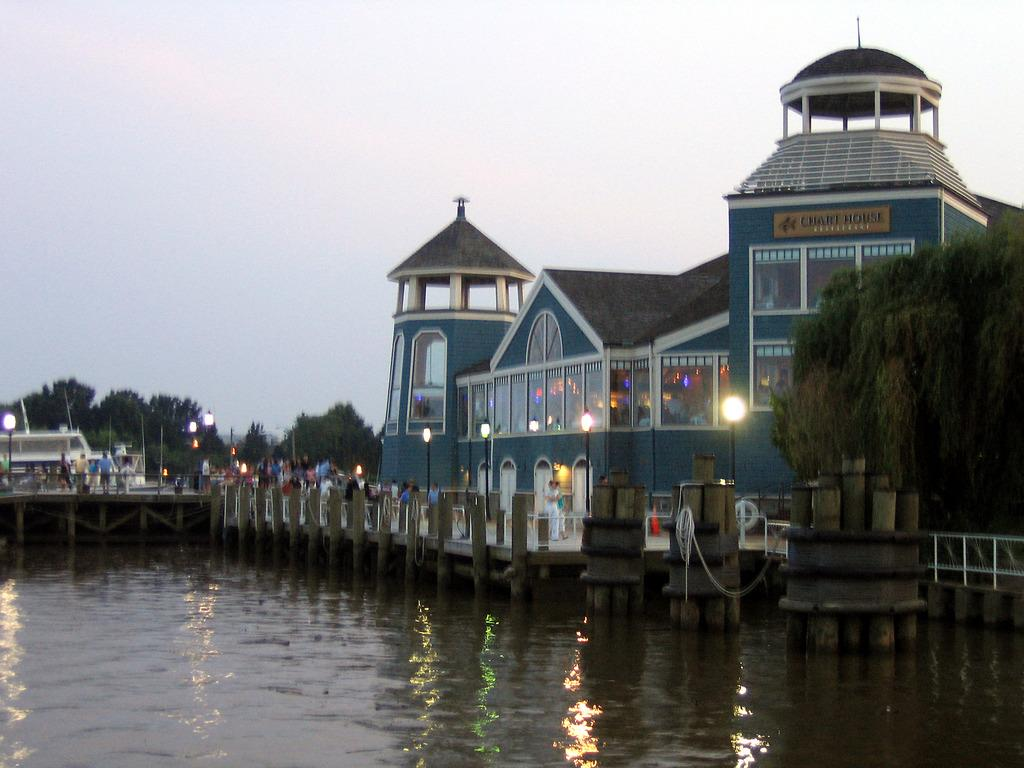Provide a one-sentence caption for the provided image. Many people stand on the pier outside of the Chart House. 